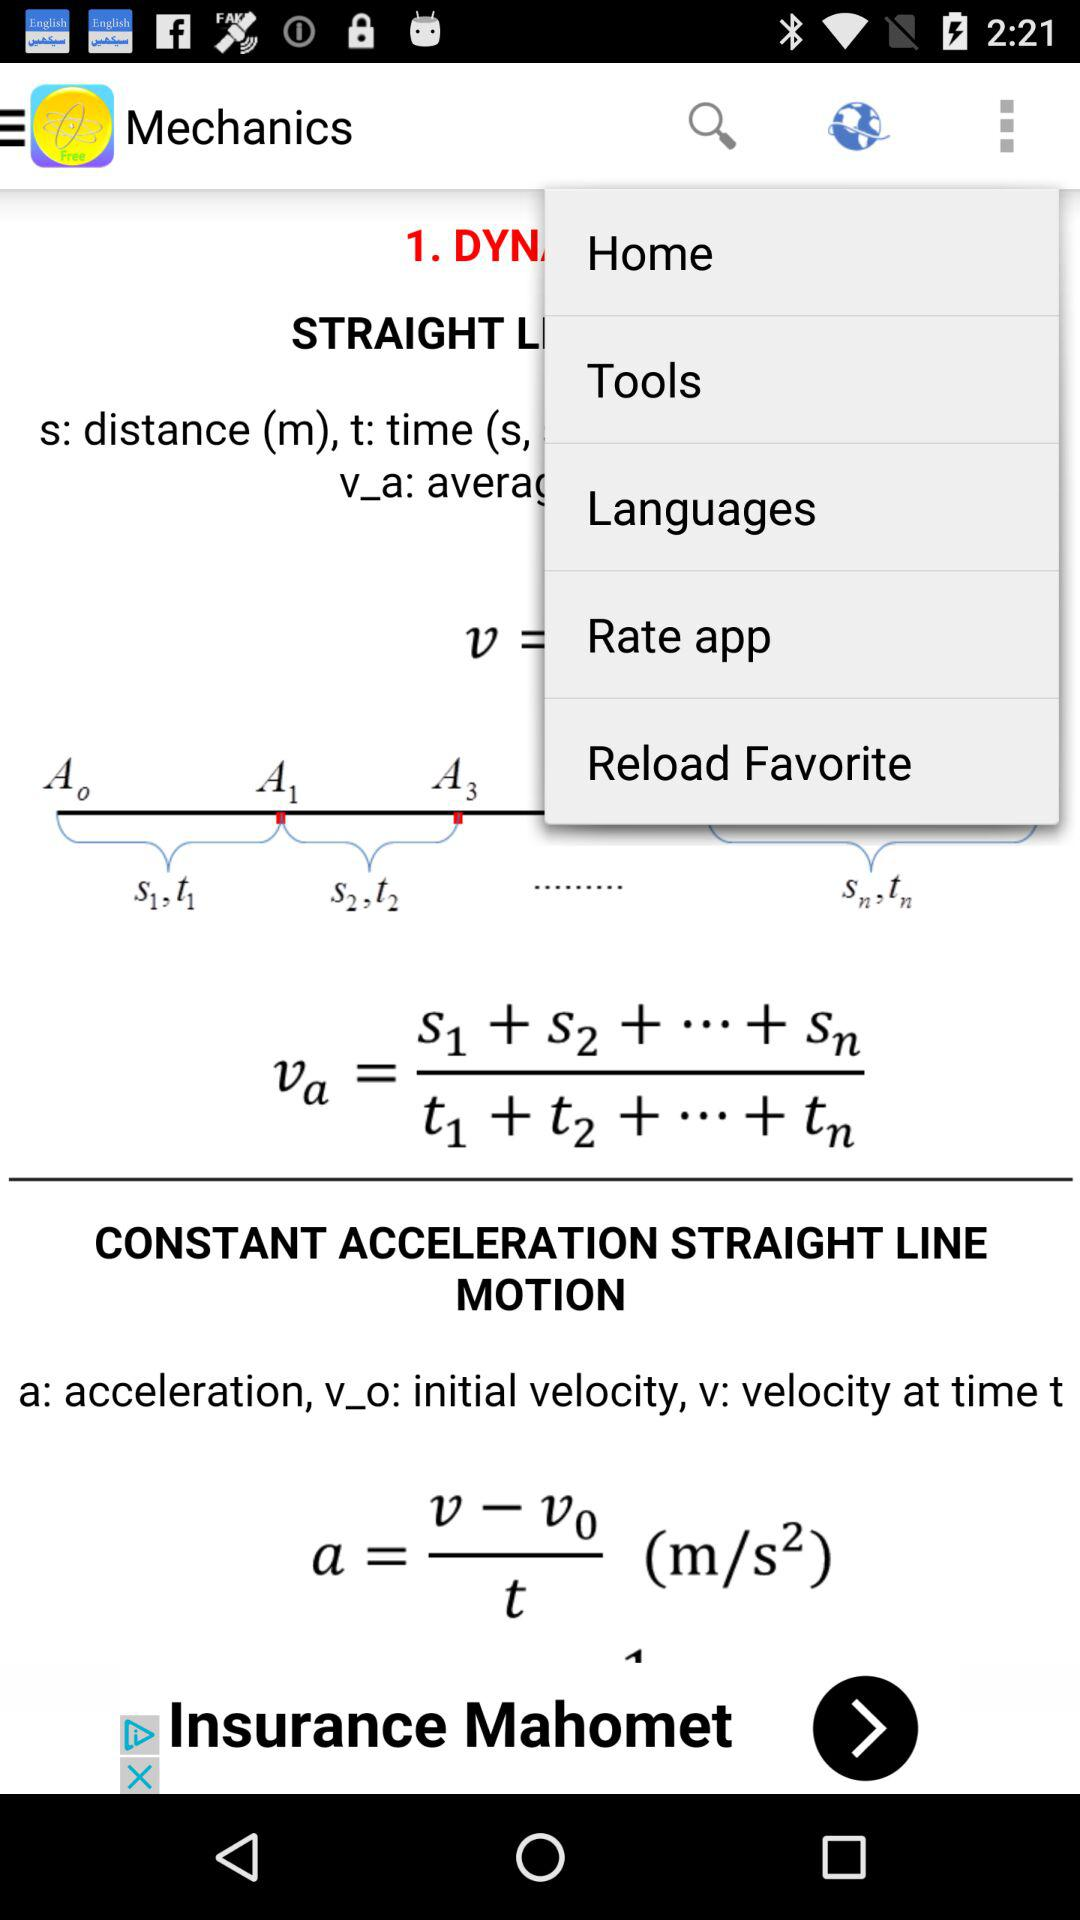What are the parameters used in the constant acceleration straight line motion equation? The parameters used are a: acceleration, v_o: initial velocity and v: velocity at time t. 